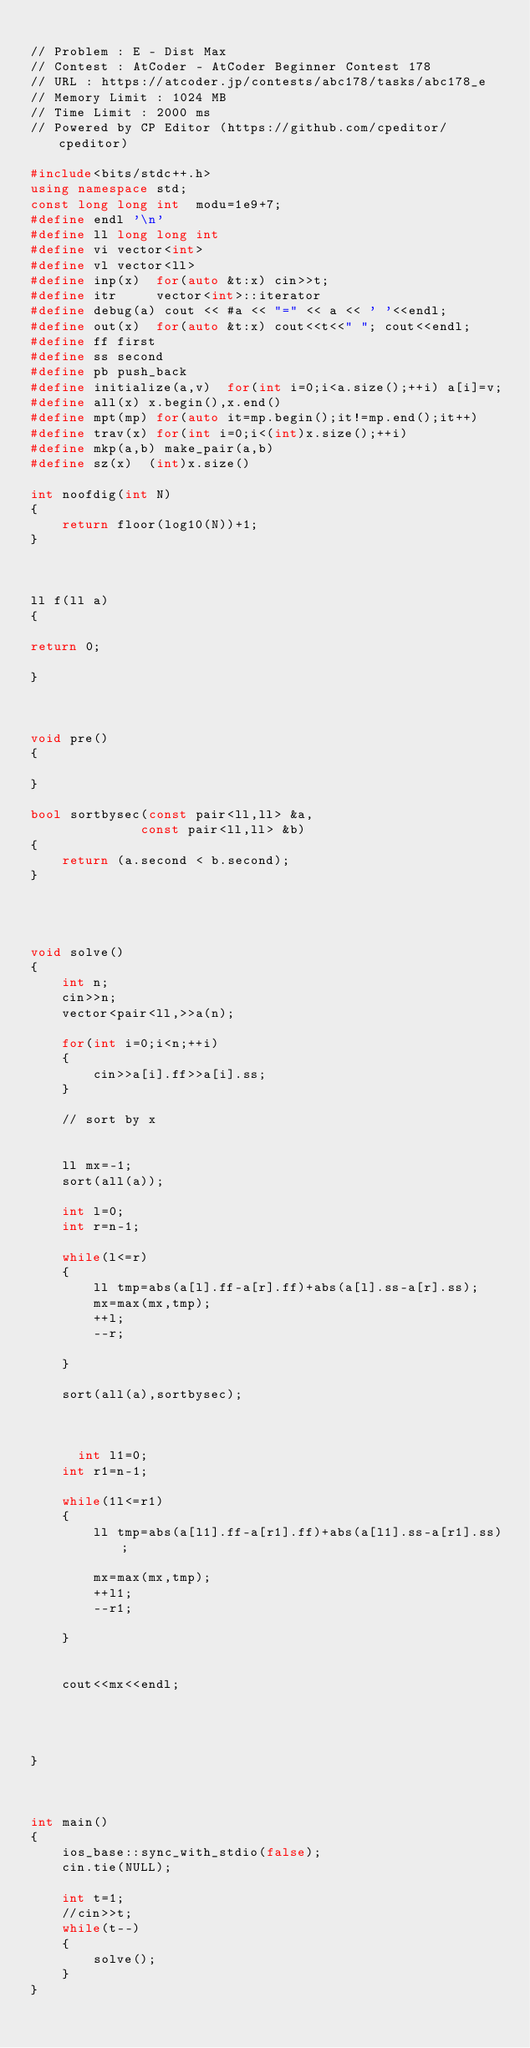Convert code to text. <code><loc_0><loc_0><loc_500><loc_500><_C++_>
// Problem : E - Dist Max
// Contest : AtCoder - AtCoder Beginner Contest 178
// URL : https://atcoder.jp/contests/abc178/tasks/abc178_e
// Memory Limit : 1024 MB
// Time Limit : 2000 ms
// Powered by CP Editor (https://github.com/cpeditor/cpeditor)

#include<bits/stdc++.h>
using namespace std;
const long long int  modu=1e9+7;
#define endl '\n'
#define ll long long int
#define vi vector<int>
#define vl vector<ll>
#define inp(x)  for(auto &t:x) cin>>t;
#define itr     vector<int>::iterator
#define debug(a) cout << #a << "=" << a << ' '<<endl;
#define out(x)  for(auto &t:x) cout<<t<<" "; cout<<endl;
#define ff first
#define ss second
#define pb push_back
#define initialize(a,v)  for(int i=0;i<a.size();++i) a[i]=v;
#define all(x) x.begin(),x.end()
#define mpt(mp) for(auto it=mp.begin();it!=mp.end();it++)
#define trav(x) for(int i=0;i<(int)x.size();++i)
#define mkp(a,b) make_pair(a,b)
#define sz(x)  (int)x.size()

int noofdig(int N)
{
	return floor(log10(N))+1;
}



ll f(ll a)
{

return 0;

}



void pre()
{

}

bool sortbysec(const pair<ll,ll> &a, 
              const pair<ll,ll> &b) 
{ 
    return (a.second < b.second); 
} 
  



void solve()
{
	int n;
	cin>>n;
	vector<pair<ll,>>a(n);
	
	for(int i=0;i<n;++i)
	{
		cin>>a[i].ff>>a[i].ss;
	}
	
	// sort by x 
	
	
    ll mx=-1;
    sort(all(a));
    
    int l=0;
    int r=n-1;
    
    while(l<=r)
    {
    	ll tmp=abs(a[l].ff-a[r].ff)+abs(a[l].ss-a[r].ss);
    	mx=max(mx,tmp);
    	++l;
    	--r;
    	
    }
    
    sort(all(a),sortbysec);
    
  
    
      int l1=0;
    int r1=n-1;
    
    while(1l<=r1)
    {
    	ll tmp=abs(a[l1].ff-a[r1].ff)+abs(a[l1].ss-a[r1].ss);
    	
    	mx=max(mx,tmp);
    	++l1;
    	--r1;
    	
    }
    
    
    cout<<mx<<endl;
    
    


}



int main()
{
	ios_base::sync_with_stdio(false);
	cin.tie(NULL);

	int t=1;
	//cin>>t;
	while(t--)
	{
		solve();
	}
}
</code> 